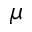<formula> <loc_0><loc_0><loc_500><loc_500>\mu</formula> 